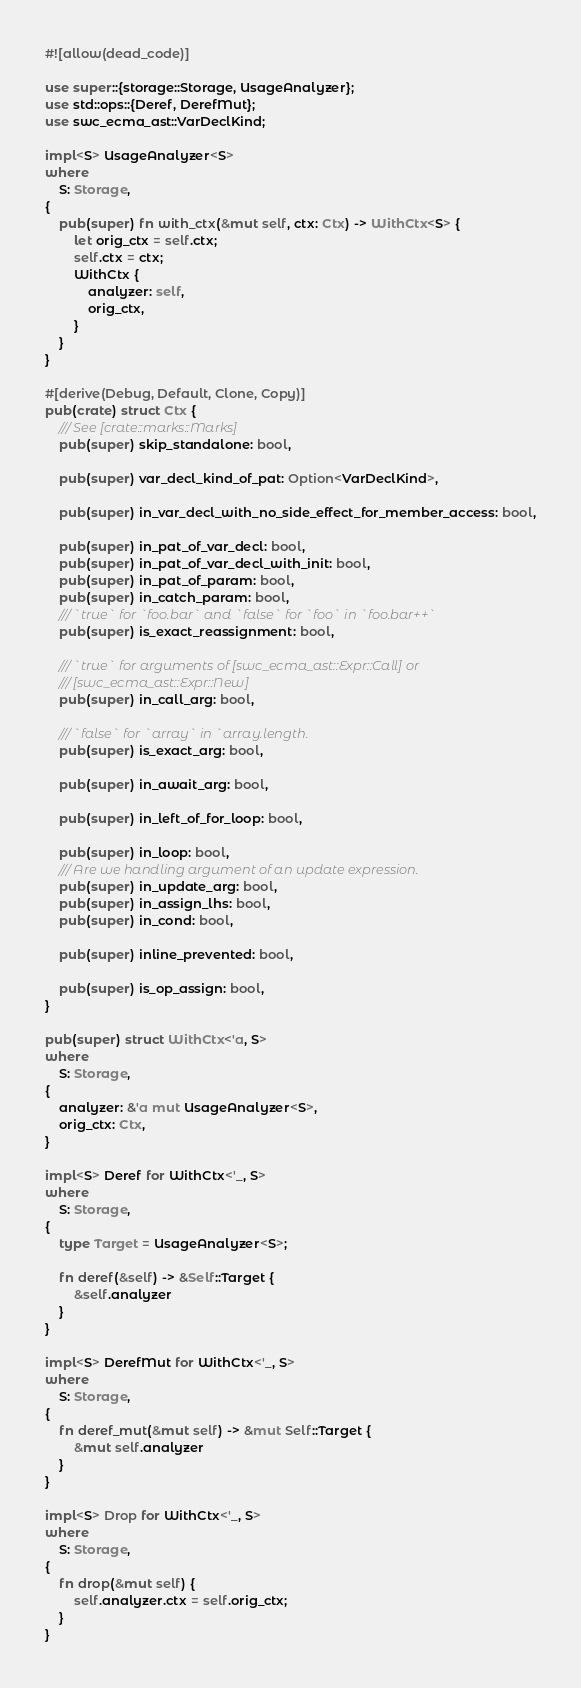Convert code to text. <code><loc_0><loc_0><loc_500><loc_500><_Rust_>#![allow(dead_code)]

use super::{storage::Storage, UsageAnalyzer};
use std::ops::{Deref, DerefMut};
use swc_ecma_ast::VarDeclKind;

impl<S> UsageAnalyzer<S>
where
    S: Storage,
{
    pub(super) fn with_ctx(&mut self, ctx: Ctx) -> WithCtx<S> {
        let orig_ctx = self.ctx;
        self.ctx = ctx;
        WithCtx {
            analyzer: self,
            orig_ctx,
        }
    }
}

#[derive(Debug, Default, Clone, Copy)]
pub(crate) struct Ctx {
    /// See [crate::marks::Marks]
    pub(super) skip_standalone: bool,

    pub(super) var_decl_kind_of_pat: Option<VarDeclKind>,

    pub(super) in_var_decl_with_no_side_effect_for_member_access: bool,

    pub(super) in_pat_of_var_decl: bool,
    pub(super) in_pat_of_var_decl_with_init: bool,
    pub(super) in_pat_of_param: bool,
    pub(super) in_catch_param: bool,
    /// `true` for `foo.bar` and `false` for `foo` in `foo.bar++`
    pub(super) is_exact_reassignment: bool,

    /// `true` for arguments of [swc_ecma_ast::Expr::Call] or
    /// [swc_ecma_ast::Expr::New]
    pub(super) in_call_arg: bool,

    /// `false` for `array` in `array.length.
    pub(super) is_exact_arg: bool,

    pub(super) in_await_arg: bool,

    pub(super) in_left_of_for_loop: bool,

    pub(super) in_loop: bool,
    /// Are we handling argument of an update expression.
    pub(super) in_update_arg: bool,
    pub(super) in_assign_lhs: bool,
    pub(super) in_cond: bool,

    pub(super) inline_prevented: bool,

    pub(super) is_op_assign: bool,
}

pub(super) struct WithCtx<'a, S>
where
    S: Storage,
{
    analyzer: &'a mut UsageAnalyzer<S>,
    orig_ctx: Ctx,
}

impl<S> Deref for WithCtx<'_, S>
where
    S: Storage,
{
    type Target = UsageAnalyzer<S>;

    fn deref(&self) -> &Self::Target {
        &self.analyzer
    }
}

impl<S> DerefMut for WithCtx<'_, S>
where
    S: Storage,
{
    fn deref_mut(&mut self) -> &mut Self::Target {
        &mut self.analyzer
    }
}

impl<S> Drop for WithCtx<'_, S>
where
    S: Storage,
{
    fn drop(&mut self) {
        self.analyzer.ctx = self.orig_ctx;
    }
}
</code> 